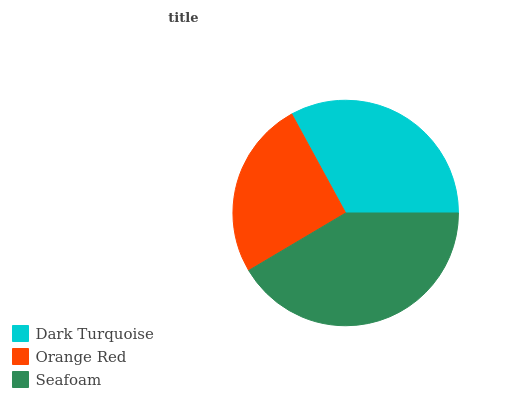Is Orange Red the minimum?
Answer yes or no. Yes. Is Seafoam the maximum?
Answer yes or no. Yes. Is Seafoam the minimum?
Answer yes or no. No. Is Orange Red the maximum?
Answer yes or no. No. Is Seafoam greater than Orange Red?
Answer yes or no. Yes. Is Orange Red less than Seafoam?
Answer yes or no. Yes. Is Orange Red greater than Seafoam?
Answer yes or no. No. Is Seafoam less than Orange Red?
Answer yes or no. No. Is Dark Turquoise the high median?
Answer yes or no. Yes. Is Dark Turquoise the low median?
Answer yes or no. Yes. Is Seafoam the high median?
Answer yes or no. No. Is Orange Red the low median?
Answer yes or no. No. 